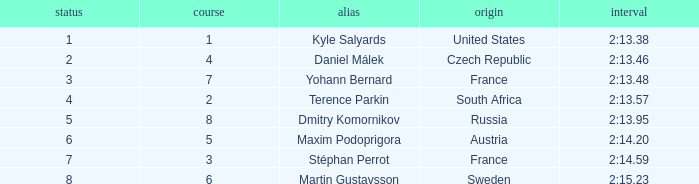What was Stéphan Perrot rank average? 7.0. 